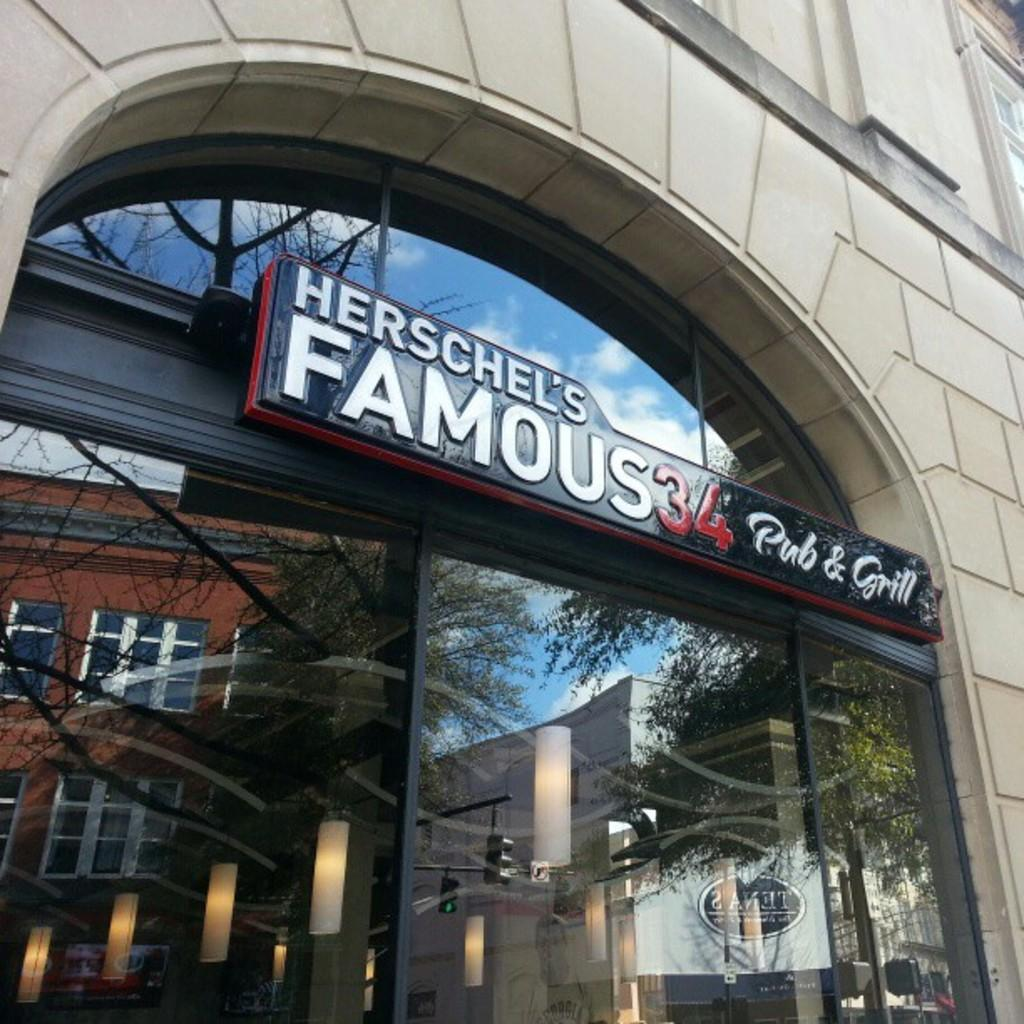What is the main subject of the image? The main subject of the image is the front view of a building. What material is the door of the building made of? The door of the building is made of glass. What can be seen in the glass door due to its reflective properties? There are reflections of other buildings and trees in the glass door. How many pets can be seen in the image? There are no pets visible in the image; it shows the front view of a building with a glass door. 